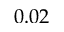<formula> <loc_0><loc_0><loc_500><loc_500>0 . 0 2</formula> 